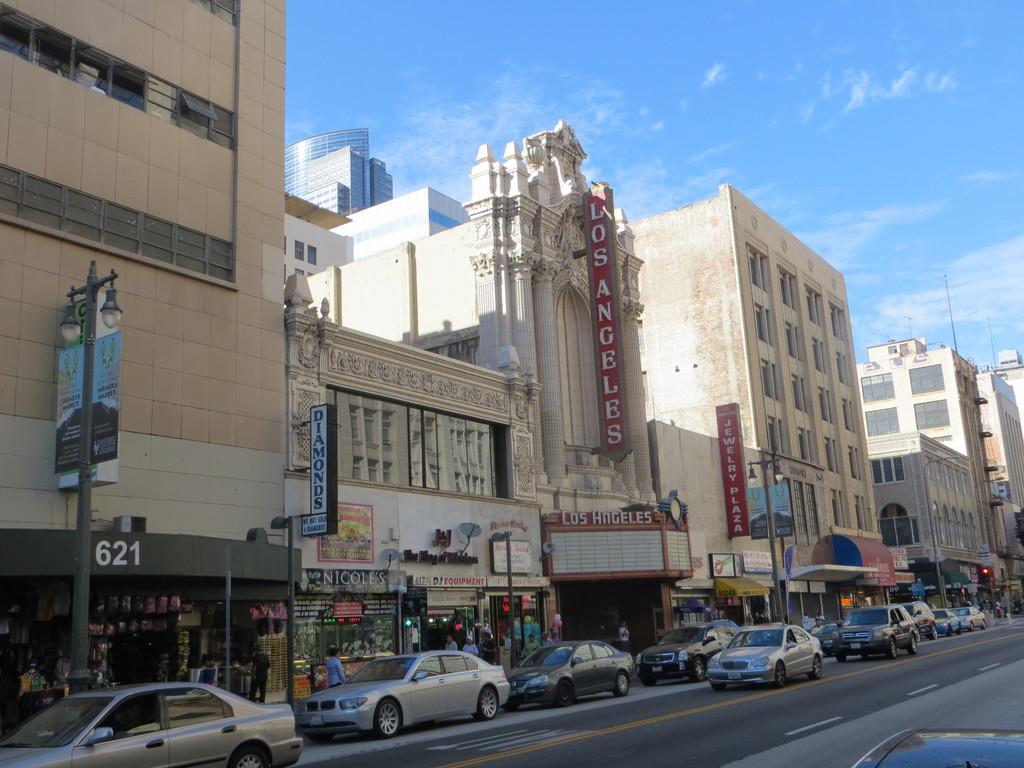Describe this image in one or two sentences. There are vehicles on the road on which, there are yellow and white color lines. In the background, there are hoardings, buildings and there are clouds in the blue sky. 